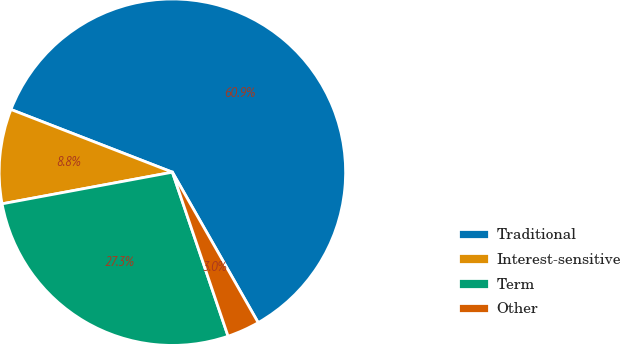Convert chart to OTSL. <chart><loc_0><loc_0><loc_500><loc_500><pie_chart><fcel>Traditional<fcel>Interest-sensitive<fcel>Term<fcel>Other<nl><fcel>60.86%<fcel>8.82%<fcel>27.29%<fcel>3.04%<nl></chart> 